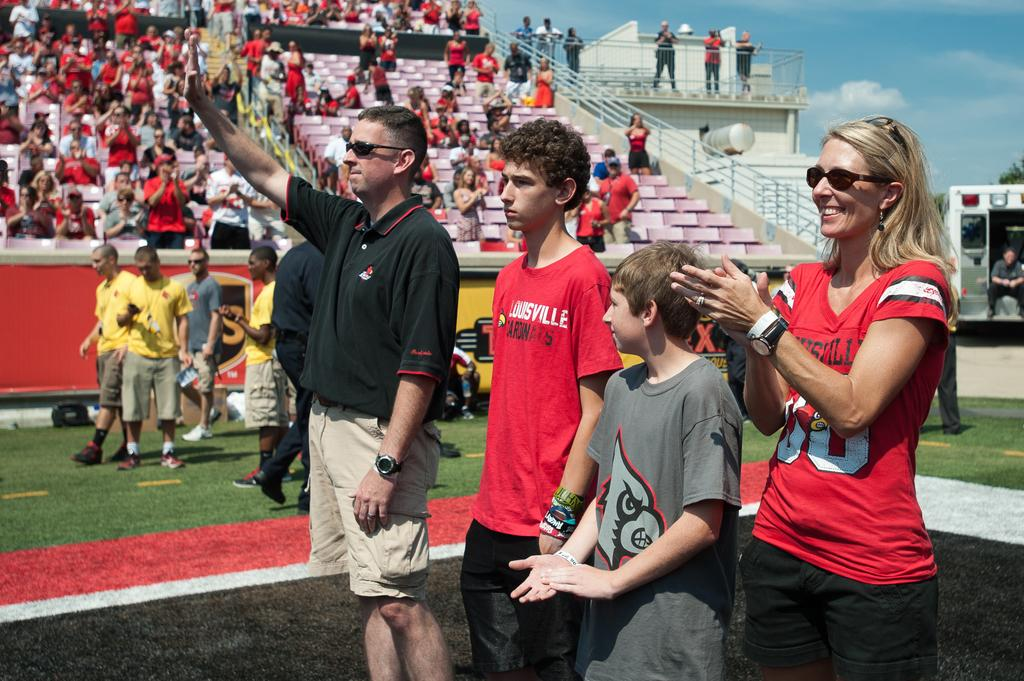What is the surface that the persons are standing on in the image? The ground is covered with grass. What can be seen above the persons in the image? There is sky visible in the image. What is the condition of the sky in the image? Clouds are present in the sky. What is happening in the background of the image? There is a crowd sitting on chairs in the background. How many laborers are working on the knot in the image? There is no knot or laborers present in the image. What type of beam can be seen supporting the structure in the image? There is no beam or structure present in the image. 